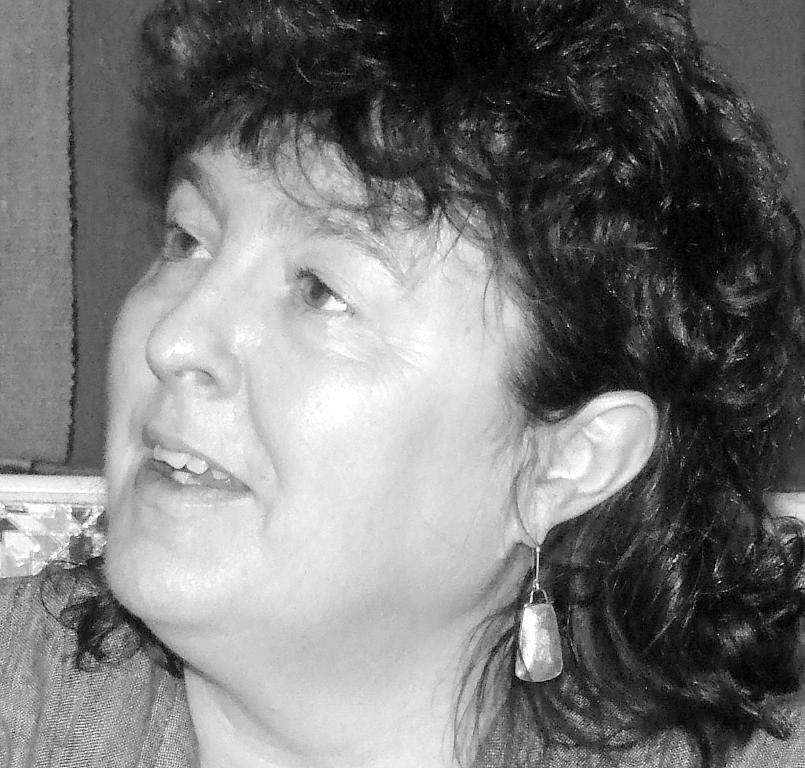Please provide a concise description of this image. This is a black and white image of a person. 